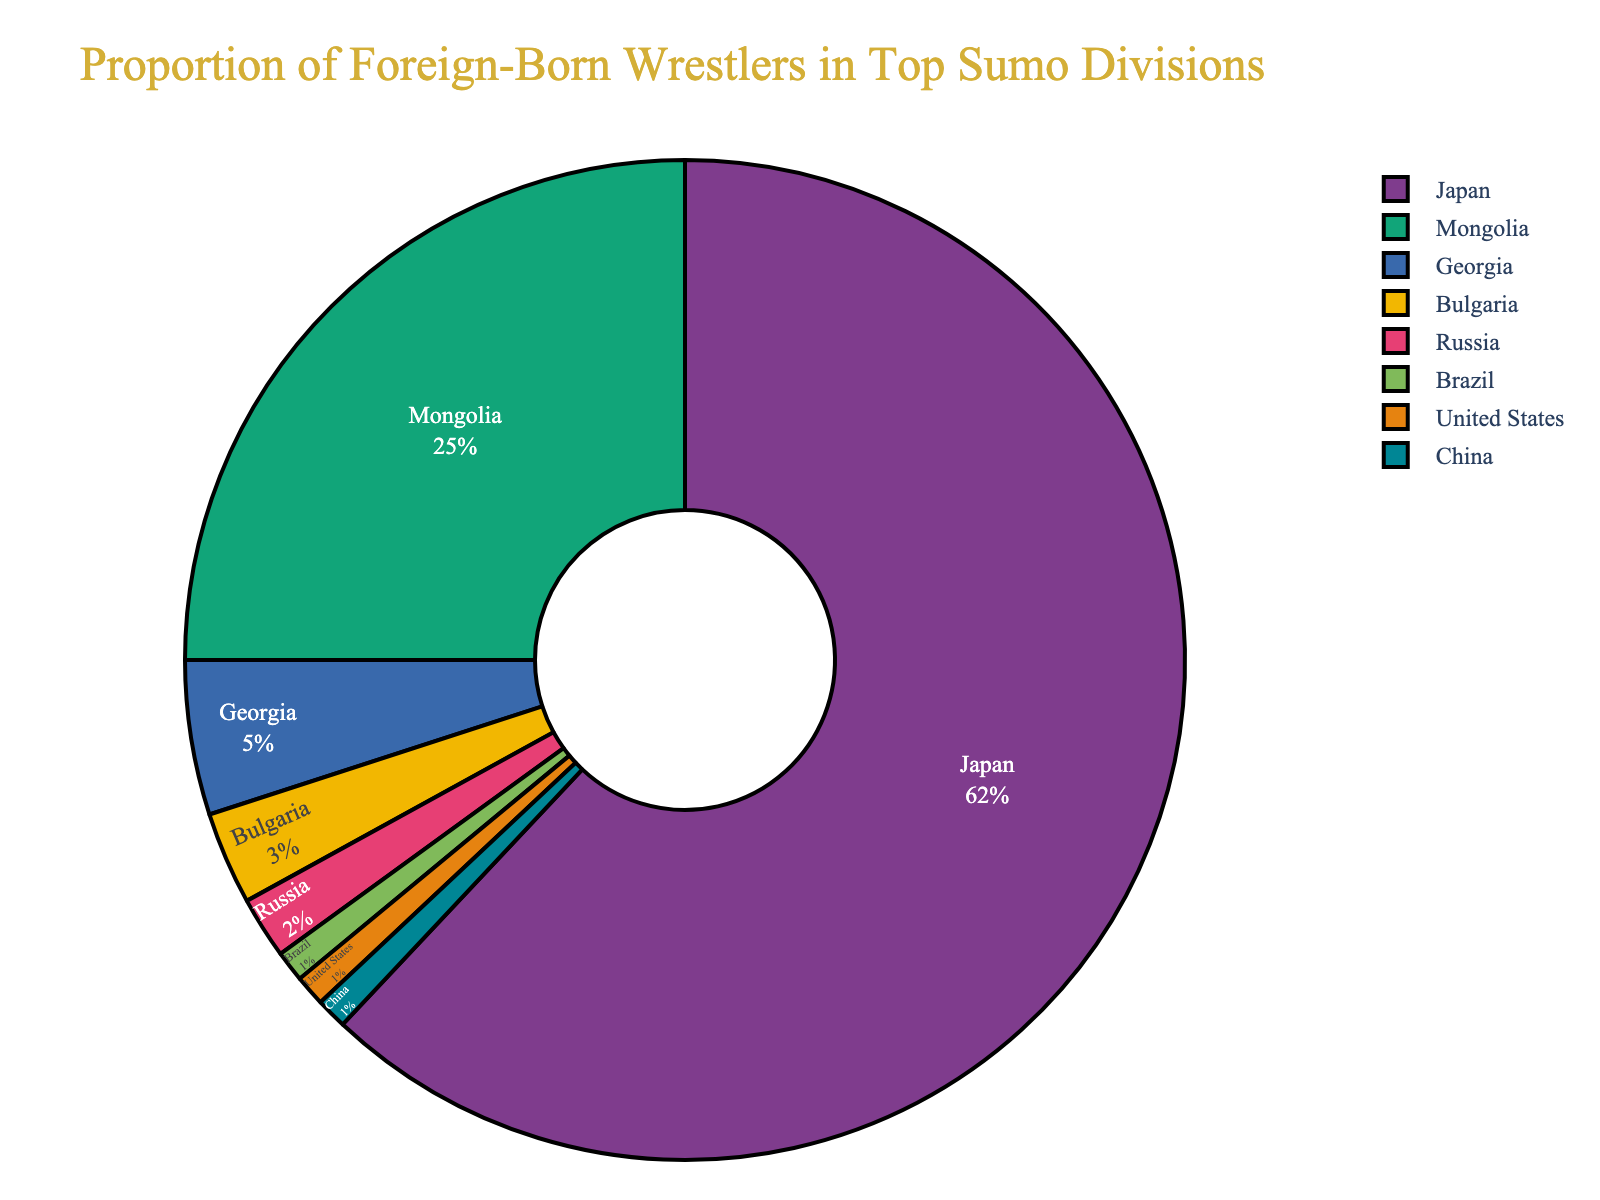Which country has the highest proportion of top sumo division wrestlers? The pie chart shows different proportions of wrestlers by country. The largest section belongs to Japan, indicating it has the highest proportion at 62%.
Answer: Japan What's the total percentage of wrestlers from Mongolia, Georgia, and Bulgaria combined? To find the combined percentage, add the individual percentages from Mongolia (25%), Georgia (5%), and Bulgaria (3%): 25 + 5 + 3 = 33%.
Answer: 33% Is the proportion of wrestlers from Brazil greater than that from the United States? The pie chart indicates both Brazil and the United States have the same proportion, shown as 1% each.
Answer: No Which country has the second-highest proportion of wrestlers in the top divisions? Japan has the highest proportion. The next largest section representing the second-highest proportion is Mongolia with 25%.
Answer: Mongolia How many countries contribute to the foreign-born wrestler population shown in the pie chart? The pie chart lists the countries and their respective percentages. Counting them gives a total of seven countries other than Japan.
Answer: 7 What's the difference in the proportion of wrestlers between Mongolia and Japan? Subtract the proportion of wrestlers from Mongolia (25%) from Japan's (62%): 62 - 25 = 37%.
Answer: 37% What does the color for Russia represent in the pie chart? The pie chart uses different colors to represent different countries. The section colored for Russia indicates a proportion of 2%.
Answer: 2% Are there more wrestlers from Georgia or Bulgaria? The pie chart shows Georgia's proportion at 5% and Bulgaria's at 3%. Therefore, there are more wrestlers from Georgia.
Answer: Georgia How does the proportion of wrestlers from Japan compare to the rest of the world combined? To compare, subtract Japan's proportion (62%) from 100% to get the combined proportion of all other countries: 100 - 62 = 38%.
Answer: Japan has more What's the proportion of wrestlers from countries with less than 5% representation each? Add the percentages of countries with less than 5% (Georgia 5%, Bulgaria 3%, Russia 2%, Brazil 1%, United States 1%, China 1%): 5 + 3 + 2 + 1 + 1 + 1 = 13%.
Answer: 13% 